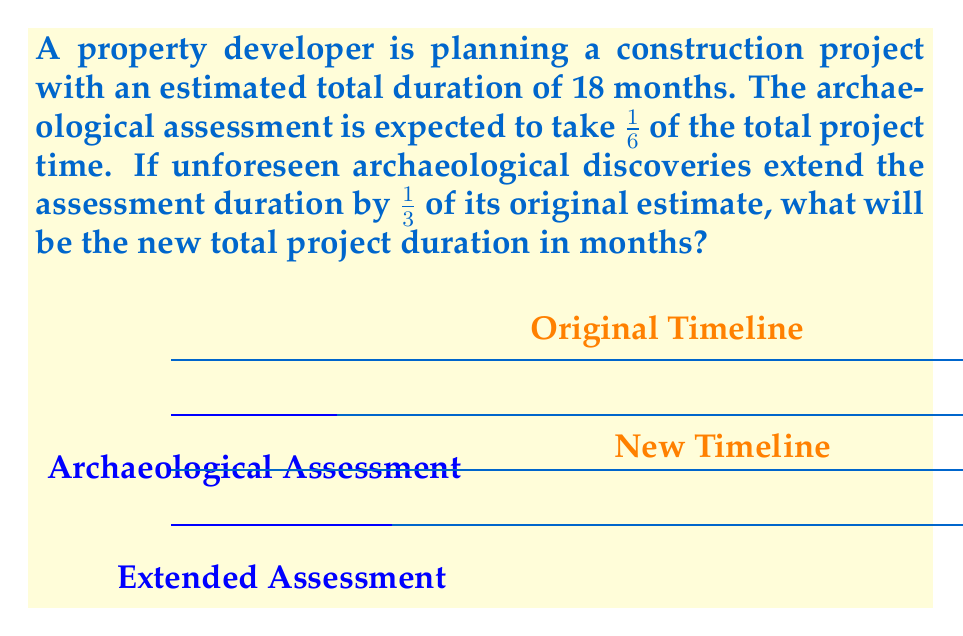Teach me how to tackle this problem. Let's solve this step-by-step:

1) First, calculate the original duration of the archaeological assessment:
   $\frac{1}{6}$ of 18 months = $18 \cdot \frac{1}{6} = 3$ months

2) Calculate the extension of the assessment:
   $\frac{1}{3}$ of 3 months = $3 \cdot \frac{1}{3} = 1$ month

3) New duration of the archaeological assessment:
   $3 + 1 = 4$ months

4) Calculate how much longer the assessment takes compared to the original plan:
   $4 - 3 = 1$ month

5) Add this extra month to the original project duration:
   $18 + 1 = 19$ months

Therefore, the new total project duration will be 19 months.
Answer: 19 months 